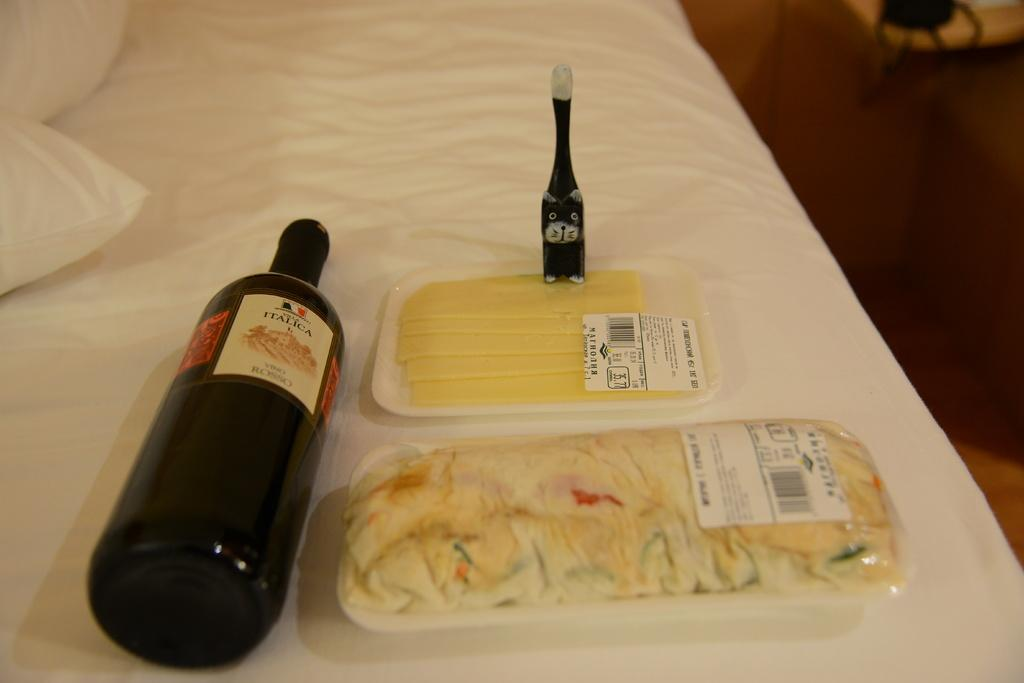<image>
Write a terse but informative summary of the picture. Bottle of wine with a label which says ITALICA. 